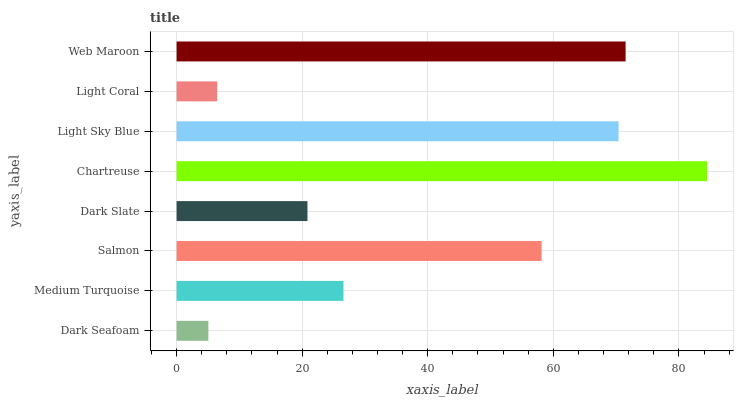Is Dark Seafoam the minimum?
Answer yes or no. Yes. Is Chartreuse the maximum?
Answer yes or no. Yes. Is Medium Turquoise the minimum?
Answer yes or no. No. Is Medium Turquoise the maximum?
Answer yes or no. No. Is Medium Turquoise greater than Dark Seafoam?
Answer yes or no. Yes. Is Dark Seafoam less than Medium Turquoise?
Answer yes or no. Yes. Is Dark Seafoam greater than Medium Turquoise?
Answer yes or no. No. Is Medium Turquoise less than Dark Seafoam?
Answer yes or no. No. Is Salmon the high median?
Answer yes or no. Yes. Is Medium Turquoise the low median?
Answer yes or no. Yes. Is Light Coral the high median?
Answer yes or no. No. Is Light Sky Blue the low median?
Answer yes or no. No. 